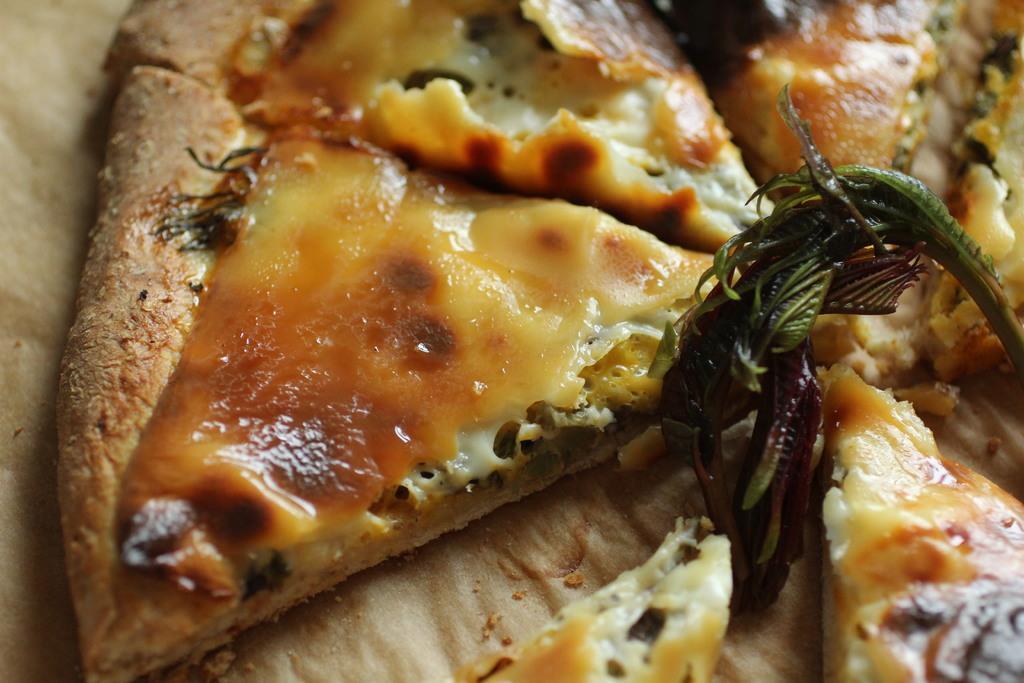Could you give a brief overview of what you see in this image? In the center of the image there is food item. 